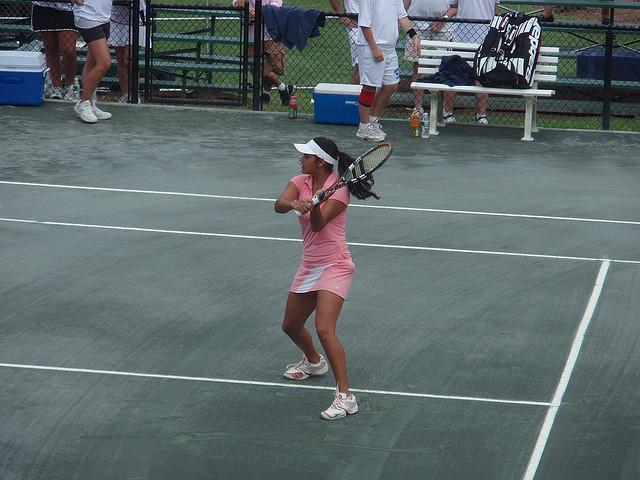What object can keep beverages cold?

Choices:
A) cooler
B) bench
C) racquet
D) shoes cooler 